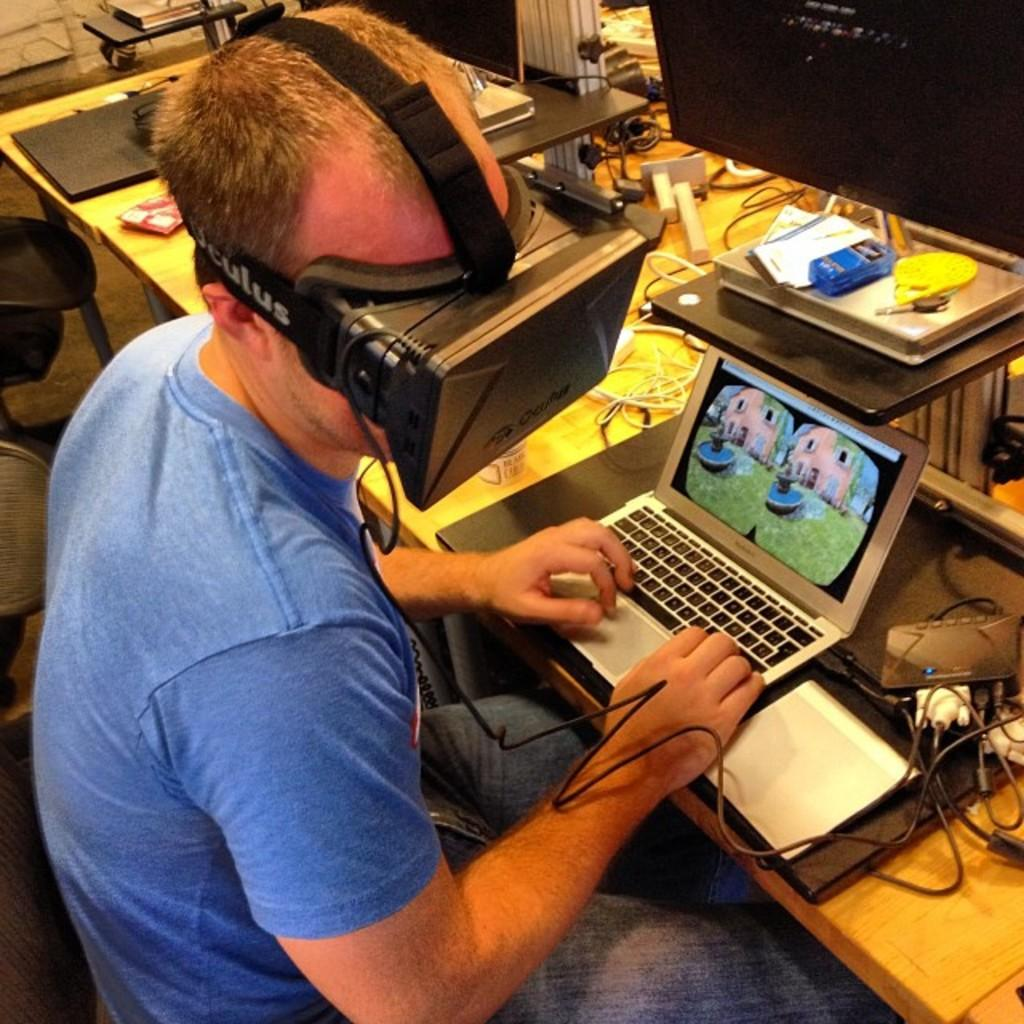<image>
Write a terse but informative summary of the picture. a small macbook laptop with pictures of a building on the screen 